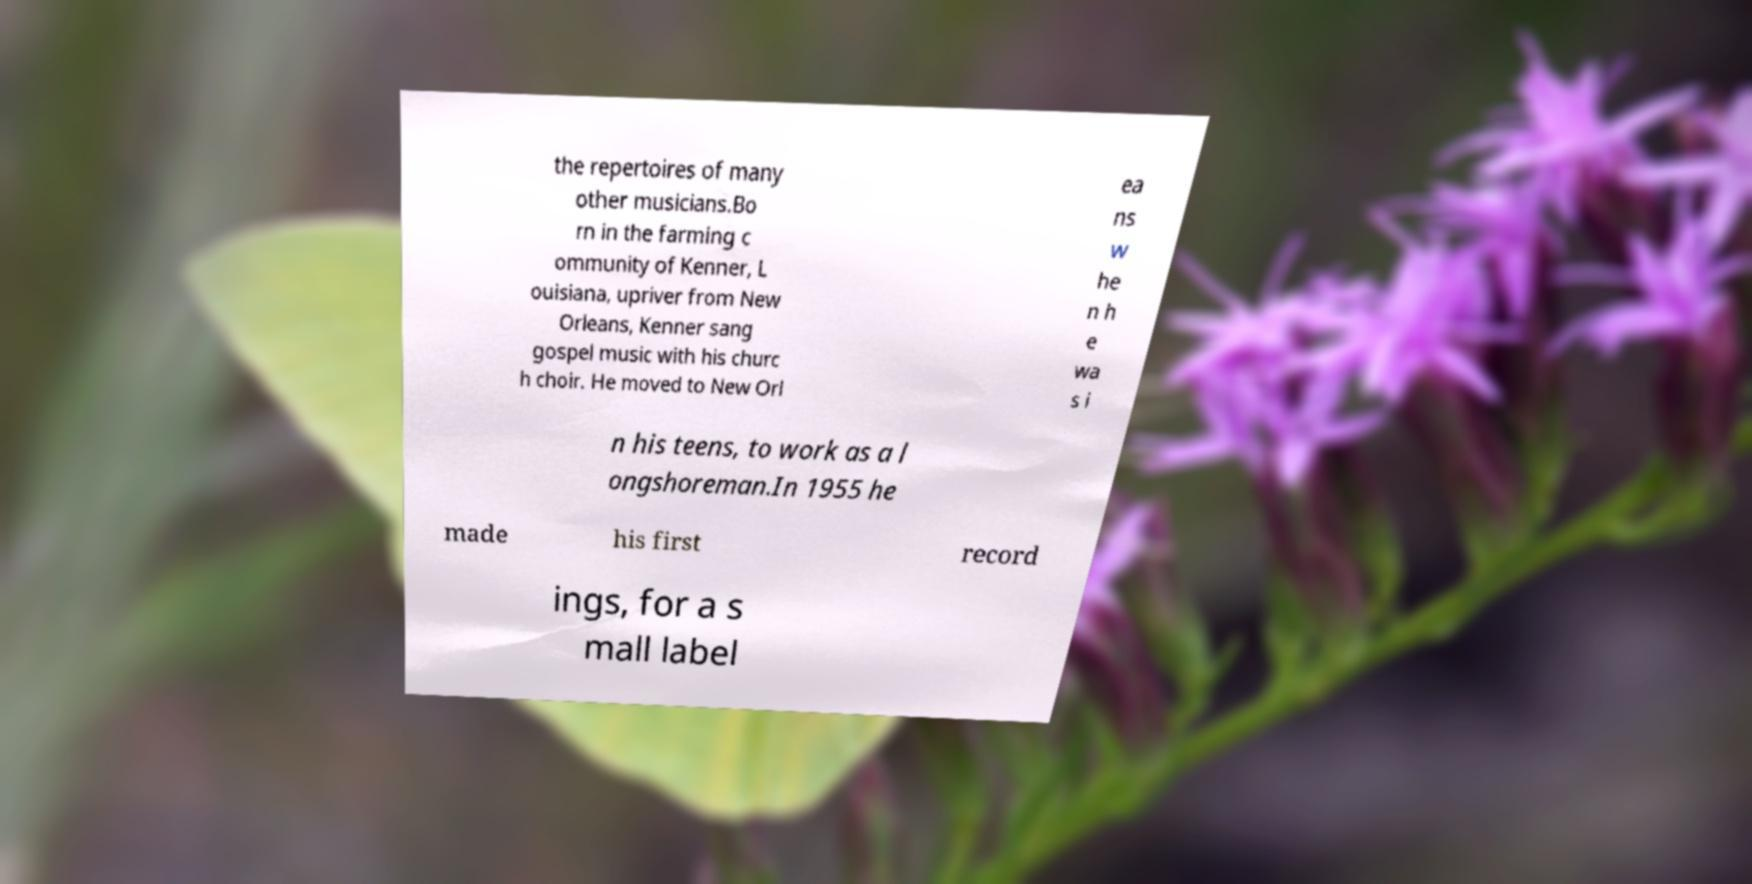Can you read and provide the text displayed in the image?This photo seems to have some interesting text. Can you extract and type it out for me? the repertoires of many other musicians.Bo rn in the farming c ommunity of Kenner, L ouisiana, upriver from New Orleans, Kenner sang gospel music with his churc h choir. He moved to New Orl ea ns w he n h e wa s i n his teens, to work as a l ongshoreman.In 1955 he made his first record ings, for a s mall label 